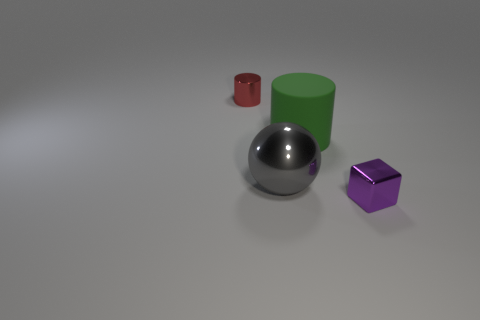Is the number of small metallic objects greater than the number of blue metal spheres?
Make the answer very short. Yes. Does the green matte cylinder have the same size as the purple metal thing?
Make the answer very short. No. How many things are either tiny blue spheres or tiny shiny things?
Offer a terse response. 2. What is the shape of the object right of the cylinder in front of the tiny metallic object behind the small purple metallic thing?
Your answer should be compact. Cube. Is the small object on the left side of the tiny purple object made of the same material as the large object that is on the right side of the big gray metal thing?
Your response must be concise. No. There is a green thing that is the same shape as the red metal thing; what is it made of?
Ensure brevity in your answer.  Rubber. Are there any other things that are the same size as the purple cube?
Ensure brevity in your answer.  Yes. There is a small metal thing left of the tiny purple object; does it have the same shape as the green rubber object right of the red thing?
Give a very brief answer. Yes. Is the number of tiny purple things to the left of the green cylinder less than the number of large green cylinders behind the cube?
Your answer should be compact. Yes. How many other objects are the same shape as the big matte thing?
Offer a terse response. 1. 